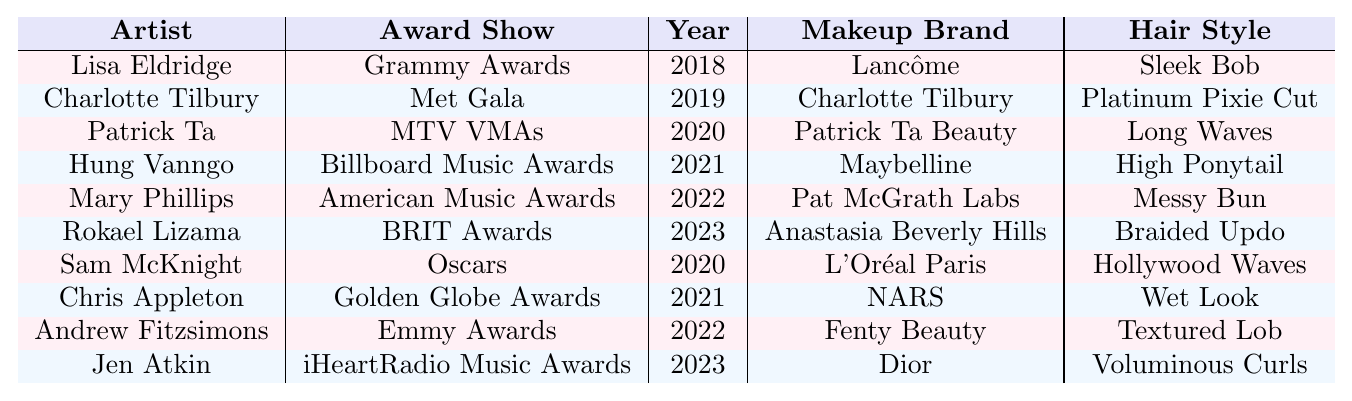What year did Lisa Eldridge work with Rita Ora? The table shows that Lisa Eldridge worked with Rita Ora at the Grammy Awards in 2018.
Answer: 2018 Which makeup brand was used at the Met Gala in 2019? According to the table, Charlotte Tilbury was the makeup brand used at the Met Gala in 2019.
Answer: Charlotte Tilbury How many different makeup brands were used across all the listed award shows? By reviewing the brands listed in the "Makeup Brand" column, we can count them: Lancôme, Charlotte Tilbury, Patrick Ta Beauty, Maybelline, Pat McGrath Labs, Anastasia Beverly Hills, L'Oréal Paris, NARS, Fenty Beauty, and Dior, totaling 10 distinct brands.
Answer: 10 Did Rita Ora wear a high ponytail at any award shows? The table indicates that a high ponytail hairstyle was used by Hung Vanngo at the Billboard Music Awards in 2021.
Answer: Yes Which artist worked with Rita Ora in the year 2023, and at what award show? Referring to the table, Rokael Lizama worked with her at the BRIT Awards in 2023, and Jen Atkin worked with her at the iHeartRadio Music Awards in the same year.
Answer: Rokael Lizama at BRIT Awards, Jen Atkin at iHeartRadio Music Awards What hairstyle was used in association with Fenty Beauty? The table shows that Andrew Fitzsimons used the Textured Lob hairstyle with Fenty Beauty at the Emmy Awards in 2022.
Answer: Textured Lob Who was the hair and makeup artist for the Oscars in 2020? According to the table, Sam McKnight was the hair artist and Rita Ora was associated with L'Oréal Paris for this award show.
Answer: Sam McKnight What is the most recent award show listed in the table? By checking the "Year" column, the most recent award show listed is the BRIT Awards in 2023.
Answer: BRIT Awards Was there any collaboration with Pat McGrath Labs? If so, what was the hairstyle? The table shows that Mary Phillips collaborated with Rita Ora using Pat McGrath Labs, and the hairstyle was a messy bun.
Answer: Yes, messy bun Which two artists collaborated with Rita Ora in 2022? From the table, Mary Phillips at the American Music Awards and Andrew Fitzsimons at the Emmy Awards both collaborated with Rita Ora in 2022.
Answer: Mary Phillips and Andrew Fitzsimons How many of the award shows featured a hairstyle with waves? The table indicates that the hairstyles associated with waves are "Long Waves" by Patrick Ta at the MTV VMAs and "Hollywood Waves" by Sam McKnight at the Oscars. Thus, 2 award shows featured hairstyles with waves.
Answer: 2 